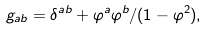Convert formula to latex. <formula><loc_0><loc_0><loc_500><loc_500>g _ { a b } = \delta ^ { a b } + \varphi ^ { a } \varphi ^ { b } / ( 1 - \varphi ^ { 2 } ) ,</formula> 